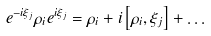Convert formula to latex. <formula><loc_0><loc_0><loc_500><loc_500>e ^ { - i \xi _ { j } } \rho _ { i } e ^ { i \xi _ { j } } = \rho _ { i } + i \left [ \rho _ { i } , \xi _ { j } \right ] + \dots</formula> 